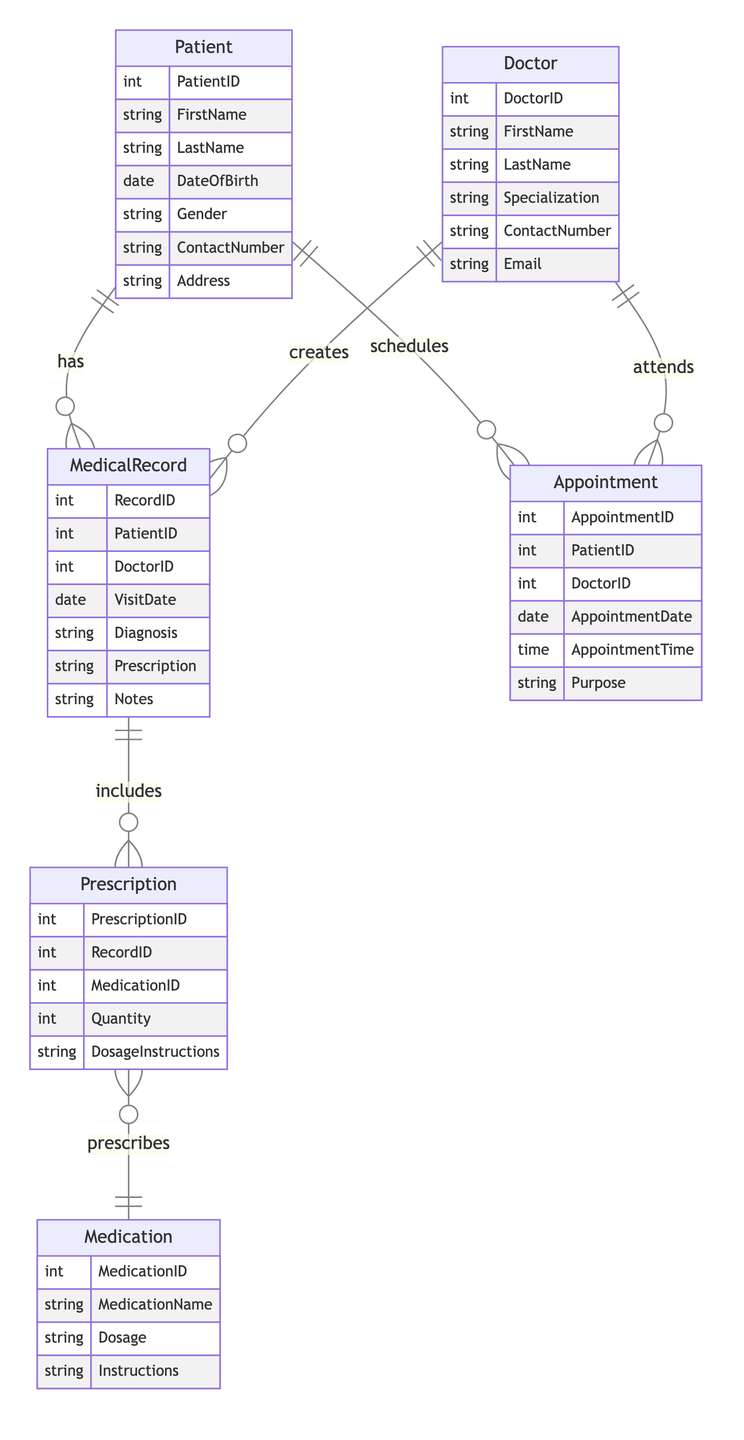What is the primary key of the Patient entity? The primary key of the Patient entity is PatientID, which uniquely identifies each patient in the system.
Answer: PatientID How many entities are present in the diagram? The diagram contains six entities: Patient, Doctor, MedicalRecord, Appointment, Medication, and Prescription.
Answer: Six What relationship exists between the Doctor and MedicalRecord entities? The relationship between the Doctor and MedicalRecord entities is "creates," indicating that one doctor can create multiple medical records.
Answer: Creates How many attributes are there in the Doctor entity? The Doctor entity includes six attributes: DoctorID, FirstName, LastName, Specialization, ContactNumber, and Email.
Answer: Six What type of relationship is represented between MedicalRecord and Prescription? The relationship represented between MedicalRecord and Prescription is "includes," which indicates that a single medical record can include multiple prescriptions.
Answer: Includes Which entity manages Appointments? The Appointment entity is managed by both Patient and Doctor entities, as both can have one-to-many relationships with Appointment.
Answer: Patient and Doctor How many unique relationships are depicted in the diagram? The diagram depicts six unique relationships connecting the entities: PatientHasMedicalRecords, DoctorCreatesMedicalRecords, PatientHasAppointments, DoctorHasAppointments, MedicalRecordHasPrescription, and PrescriptionIncludesMedication.
Answer: Six Which entity does the Medication entity relate to in the diagram? The Medication entity relates to the Prescription entity, indicating that each prescription can include information about multiple medications.
Answer: Prescription How many times can a Patient have MedicalRecords according to the diagram? According to the diagram, a Patient can have many MedicalRecords, demonstrating a one-to-many relationship.
Answer: Many 